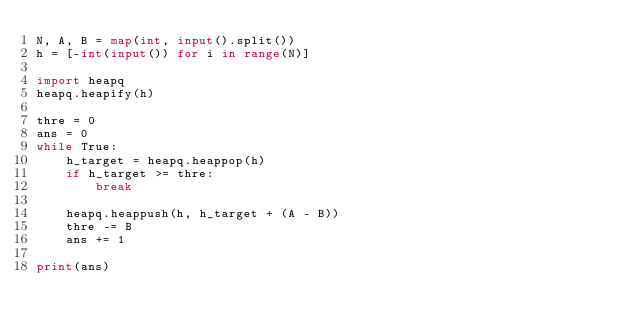<code> <loc_0><loc_0><loc_500><loc_500><_Python_>N, A, B = map(int, input().split())
h = [-int(input()) for i in range(N)]

import heapq
heapq.heapify(h)

thre = 0
ans = 0
while True:
    h_target = heapq.heappop(h)
    if h_target >= thre:
        break

    heapq.heappush(h, h_target + (A - B))
    thre -= B
    ans += 1

print(ans)
</code> 